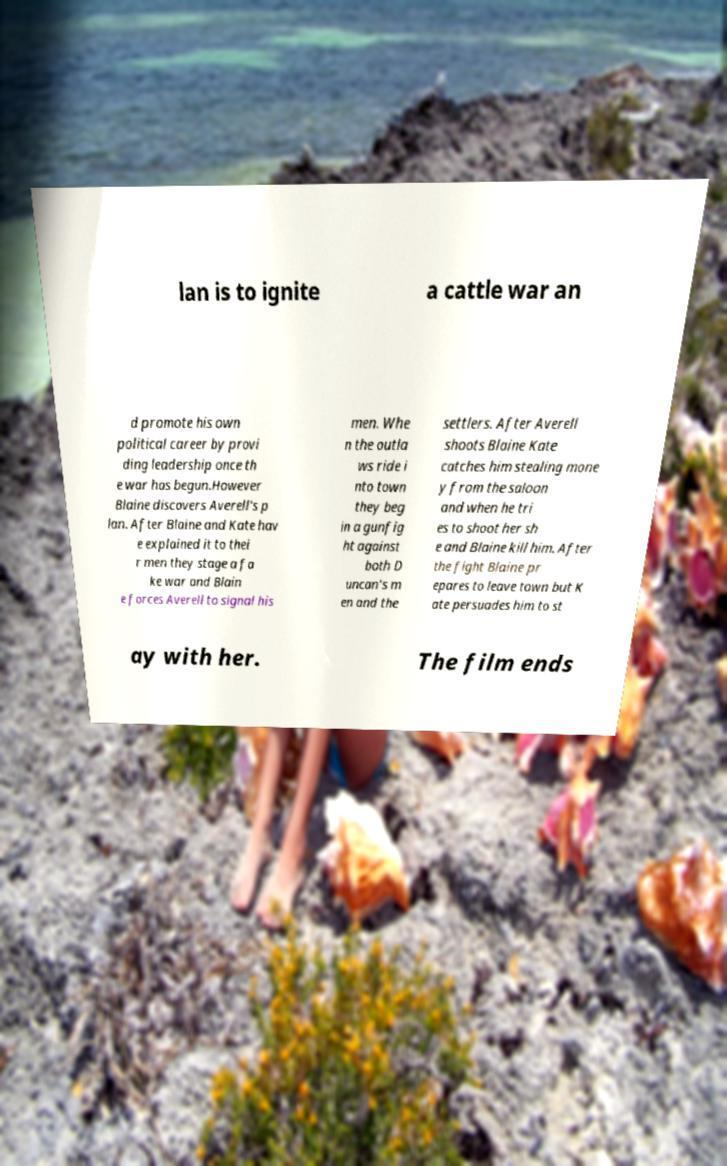Could you extract and type out the text from this image? lan is to ignite a cattle war an d promote his own political career by provi ding leadership once th e war has begun.However Blaine discovers Averell's p lan. After Blaine and Kate hav e explained it to thei r men they stage a fa ke war and Blain e forces Averell to signal his men. Whe n the outla ws ride i nto town they beg in a gunfig ht against both D uncan's m en and the settlers. After Averell shoots Blaine Kate catches him stealing mone y from the saloon and when he tri es to shoot her sh e and Blaine kill him. After the fight Blaine pr epares to leave town but K ate persuades him to st ay with her. The film ends 